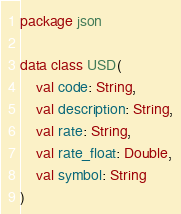<code> <loc_0><loc_0><loc_500><loc_500><_Kotlin_>package json

data class USD(
    val code: String,
    val description: String,
    val rate: String,
    val rate_float: Double,
    val symbol: String
)</code> 